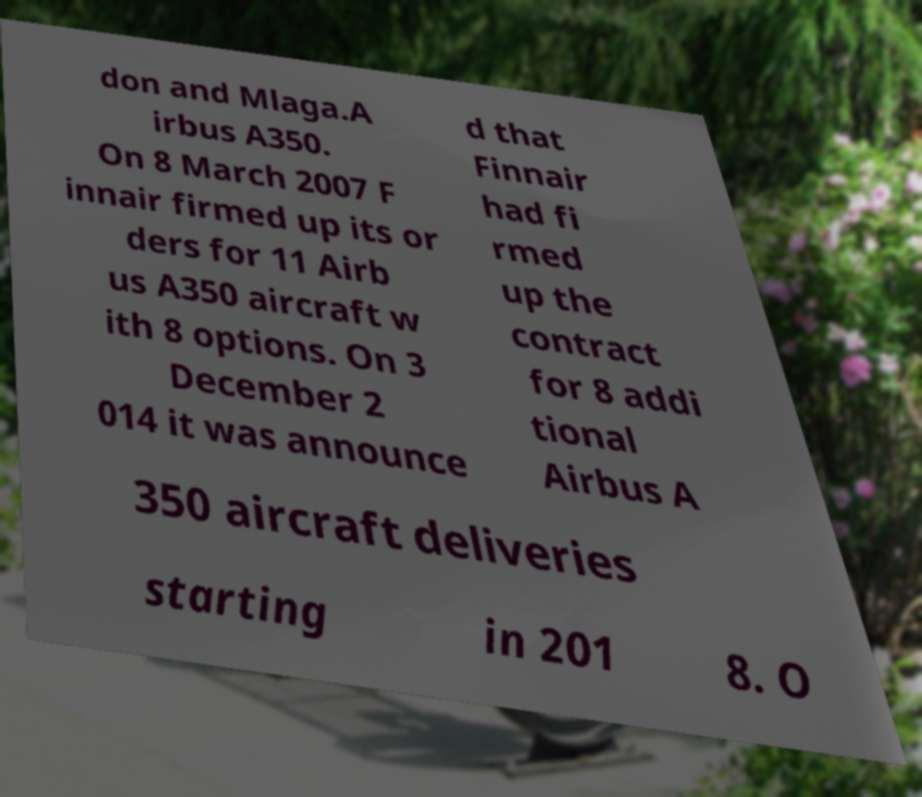Please identify and transcribe the text found in this image. don and Mlaga.A irbus A350. On 8 March 2007 F innair firmed up its or ders for 11 Airb us A350 aircraft w ith 8 options. On 3 December 2 014 it was announce d that Finnair had fi rmed up the contract for 8 addi tional Airbus A 350 aircraft deliveries starting in 201 8. O 